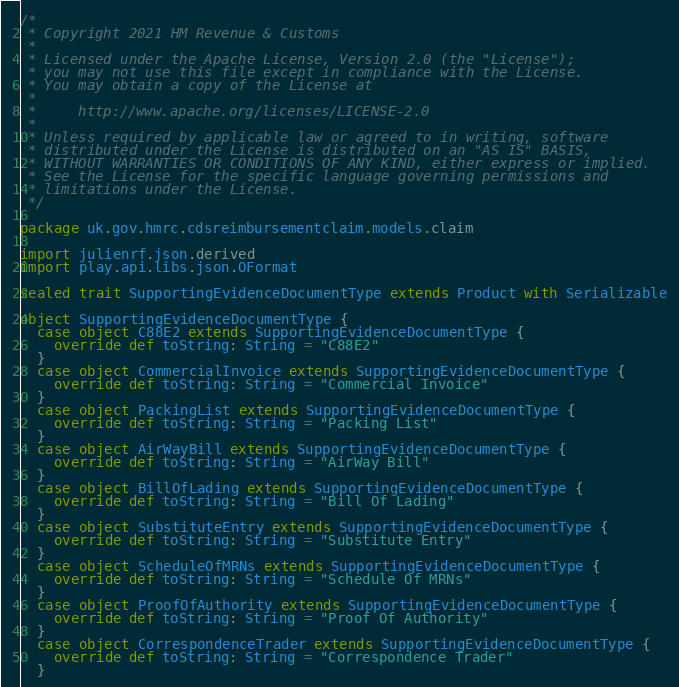<code> <loc_0><loc_0><loc_500><loc_500><_Scala_>/*
 * Copyright 2021 HM Revenue & Customs
 *
 * Licensed under the Apache License, Version 2.0 (the "License");
 * you may not use this file except in compliance with the License.
 * You may obtain a copy of the License at
 *
 *     http://www.apache.org/licenses/LICENSE-2.0
 *
 * Unless required by applicable law or agreed to in writing, software
 * distributed under the License is distributed on an "AS IS" BASIS,
 * WITHOUT WARRANTIES OR CONDITIONS OF ANY KIND, either express or implied.
 * See the License for the specific language governing permissions and
 * limitations under the License.
 */

package uk.gov.hmrc.cdsreimbursementclaim.models.claim

import julienrf.json.derived
import play.api.libs.json.OFormat

sealed trait SupportingEvidenceDocumentType extends Product with Serializable

object SupportingEvidenceDocumentType {
  case object C88E2 extends SupportingEvidenceDocumentType {
    override def toString: String = "C88E2"
  }
  case object CommercialInvoice extends SupportingEvidenceDocumentType {
    override def toString: String = "Commercial Invoice"
  }
  case object PackingList extends SupportingEvidenceDocumentType {
    override def toString: String = "Packing List"
  }
  case object AirWayBill extends SupportingEvidenceDocumentType {
    override def toString: String = "AirWay Bill"
  }
  case object BillOfLading extends SupportingEvidenceDocumentType {
    override def toString: String = "Bill Of Lading"
  }
  case object SubstituteEntry extends SupportingEvidenceDocumentType {
    override def toString: String = "Substitute Entry"
  }
  case object ScheduleOfMRNs extends SupportingEvidenceDocumentType {
    override def toString: String = "Schedule Of MRNs"
  }
  case object ProofOfAuthority extends SupportingEvidenceDocumentType {
    override def toString: String = "Proof Of Authority"
  }
  case object CorrespondenceTrader extends SupportingEvidenceDocumentType {
    override def toString: String = "Correspondence Trader"
  }</code> 